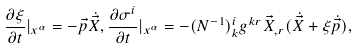<formula> <loc_0><loc_0><loc_500><loc_500>\frac { \partial \xi } { \partial t } | _ { x ^ { \alpha } } = - \vec { p } \dot { \vec { X } } , \frac { \partial \sigma ^ { i } } { \partial t } | _ { x ^ { \alpha } } = - ( N ^ { - 1 } ) _ { k } ^ { i } g ^ { k r } \vec { X } _ { , r } ( \dot { \vec { X } } + \xi \dot { \vec { p } } ) ,</formula> 